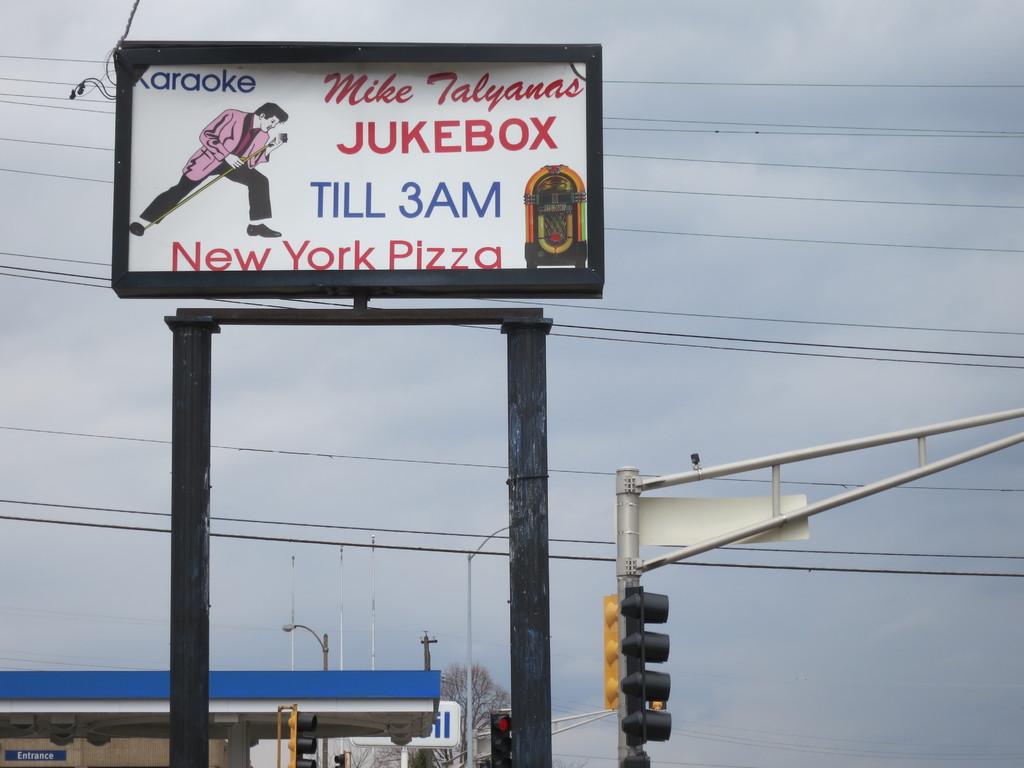What singer is on the sign?
Provide a succinct answer. Answering does not require reading text in the image. 